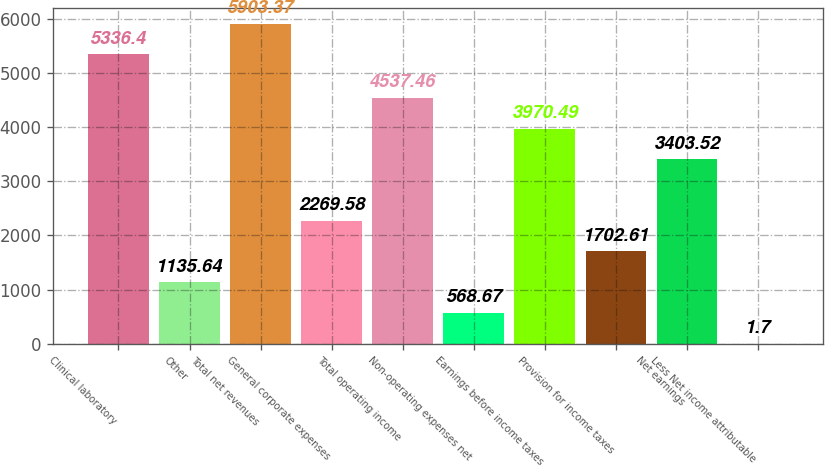<chart> <loc_0><loc_0><loc_500><loc_500><bar_chart><fcel>Clinical laboratory<fcel>Other<fcel>Total net revenues<fcel>General corporate expenses<fcel>Total operating income<fcel>Non-operating expenses net<fcel>Earnings before income taxes<fcel>Provision for income taxes<fcel>Net earnings<fcel>Less Net income attributable<nl><fcel>5336.4<fcel>1135.64<fcel>5903.37<fcel>2269.58<fcel>4537.46<fcel>568.67<fcel>3970.49<fcel>1702.61<fcel>3403.52<fcel>1.7<nl></chart> 